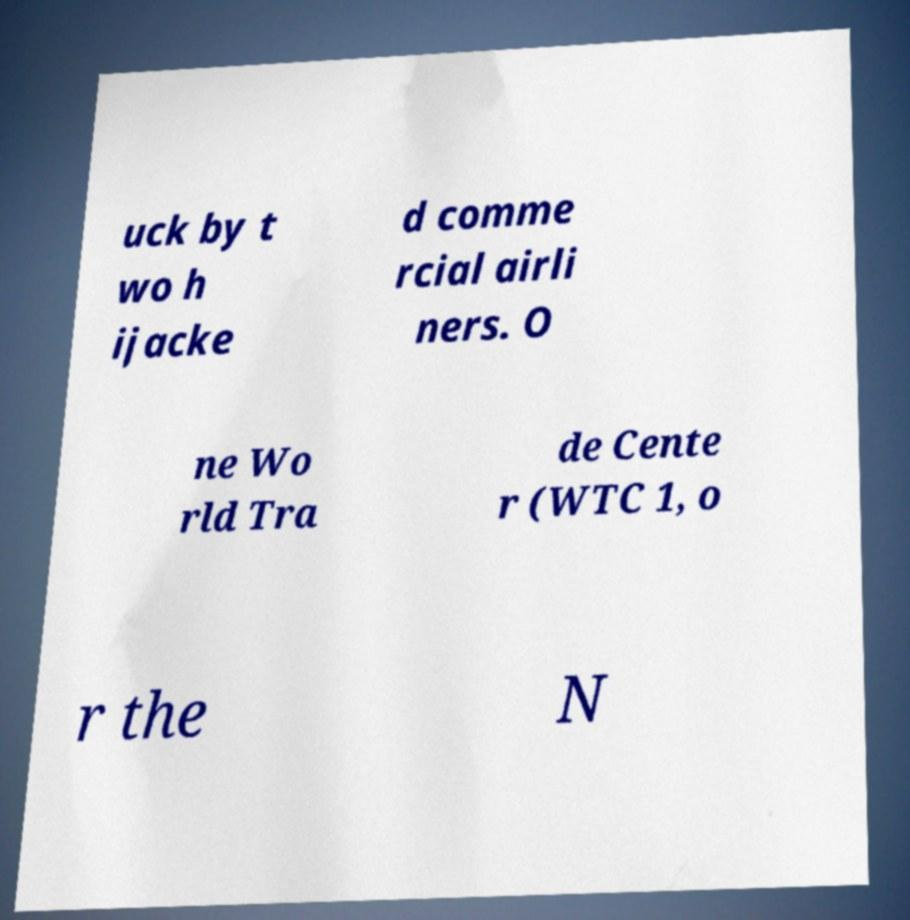I need the written content from this picture converted into text. Can you do that? uck by t wo h ijacke d comme rcial airli ners. O ne Wo rld Tra de Cente r (WTC 1, o r the N 